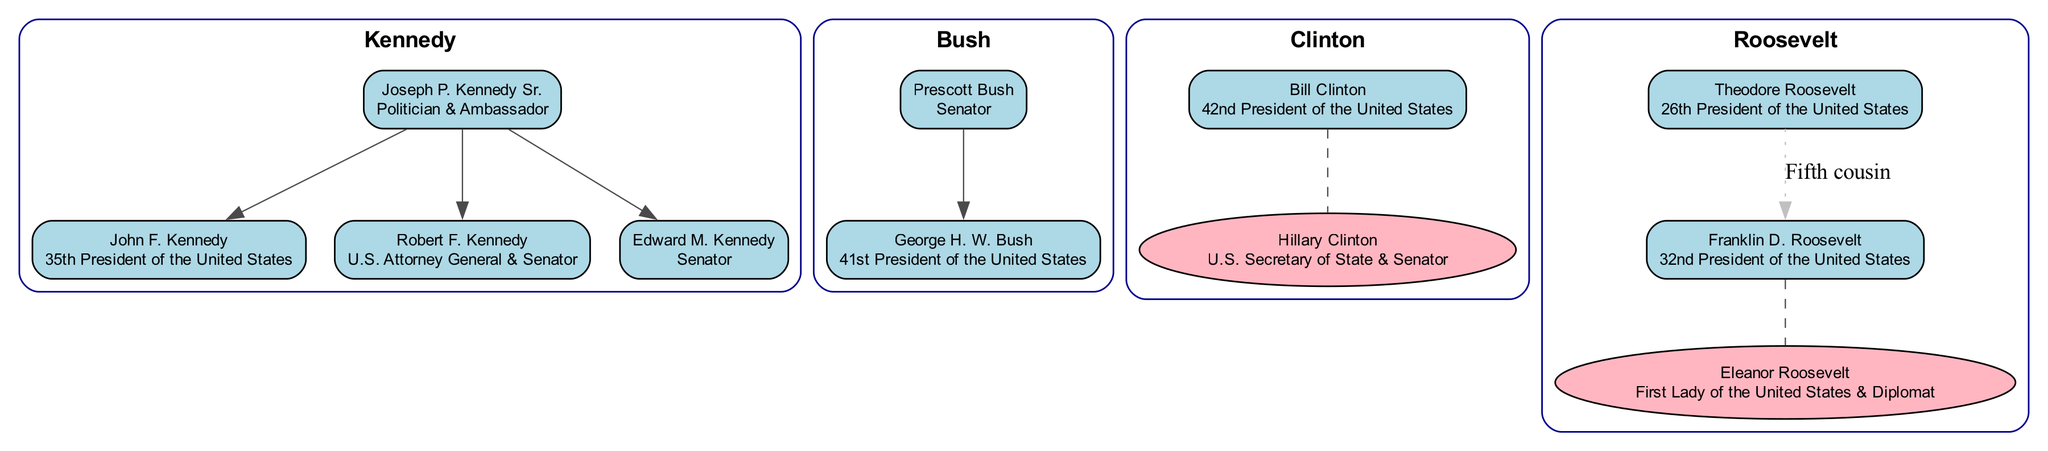What are the three children of Joseph P. Kennedy Sr.? The diagram lists three children under "Joseph P. Kennedy Sr." as follows: "John F. Kennedy", "Robert F. Kennedy", and "Edward M. Kennedy".
Answer: John F. Kennedy, Robert F. Kennedy, Edward M. Kennedy How many U.S. Presidents are included in the diagram? By examining each family, we can count: "John F. Kennedy", "George H. W. Bush", and "George W. Bush", totaling three Presidents represented in the diagram.
Answer: 3 Who is the spouse of Bill Clinton? The diagram shows the spouse of "Bill Clinton" as "Hillary Clinton", which is indicated in the family tree structure.
Answer: Hillary Clinton Which family does George W. Bush belong to? The diagram specifies that "George W. Bush" is a child of "George H. W. Bush", who is in the "Bush" family.
Answer: Bush What relationship exists between Franklin D. Roosevelt and Theodore Roosevelt? The diagram states that "Franklin D. Roosevelt" is the "Fifth cousin" of "Theodore Roosevelt", and this is specifically noted in a dotted line between them.
Answer: Fifth cousin How many generations of the Bush family are shown in the diagram? Counting from "Prescott Bush" down to "George W. Bush", we find three generations: Prescott, George H. W., and then George W. and Jeb.
Answer: 3 Which role did Eleanor Roosevelt hold? Looking at the diagram, "Eleanor Roosevelt" is labeled as the "First Lady of the United States & Diplomat", which is clearly indicated under her name.
Answer: First Lady of the United States & Diplomat Who is the only female member represented in the diagram? The diagram reveals that "Hillary Clinton" is the only female member, as all other named individuals are male, highlighted in a dashed shape.
Answer: Hillary Clinton Which family has the most members listed, including children? Analyzing the families, the "Kennedy" family has four members shown, including the three children of Joseph P. Kennedy Sr.
Answer: Kennedy 